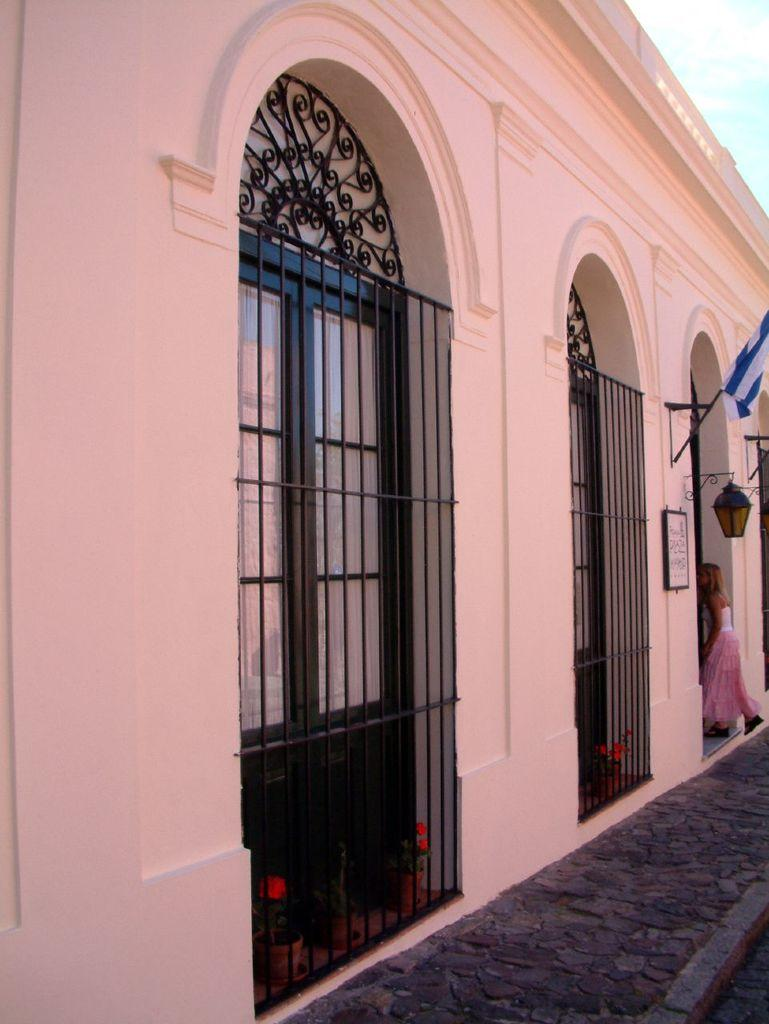What structure is present in the image? There is a building in the image. What is the girl doing in relation to the building? The girl is entering the building. What decorative element is present on the building? There is a flag on the building. What can be seen in the background of the image? The sky is visible in the background of the image. What type of cast can be seen on the girl's arm in the image? There is no cast visible on the girl's arm in the image. What idea does the flag on the building represent? The image does not provide information about the meaning or representation of the flag on the building. 